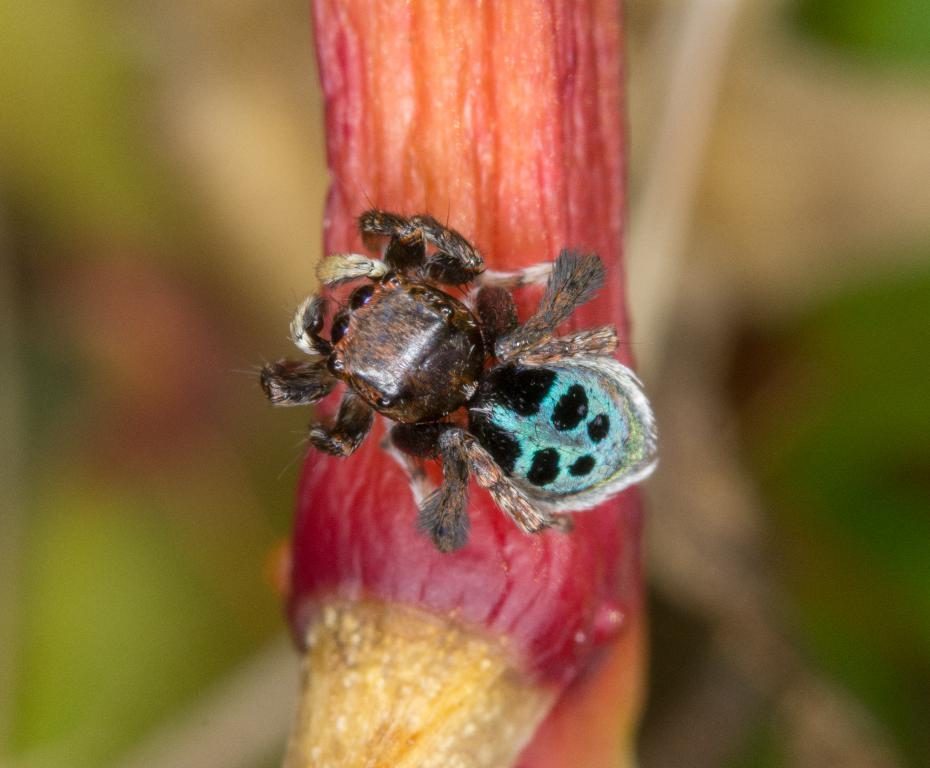What type of creature can be seen in the image? There is an insect in the image. Where is the insect located in the image? The insect is on a flower. What other object is present in the image besides the insect? There is a flower in the image. How would you describe the background of the image? The background of the image is blurred. What type of discussion is taking place in the hospital in the image? There is no discussion or hospital present in the image; it features an insect on a flower with a blurred background. 